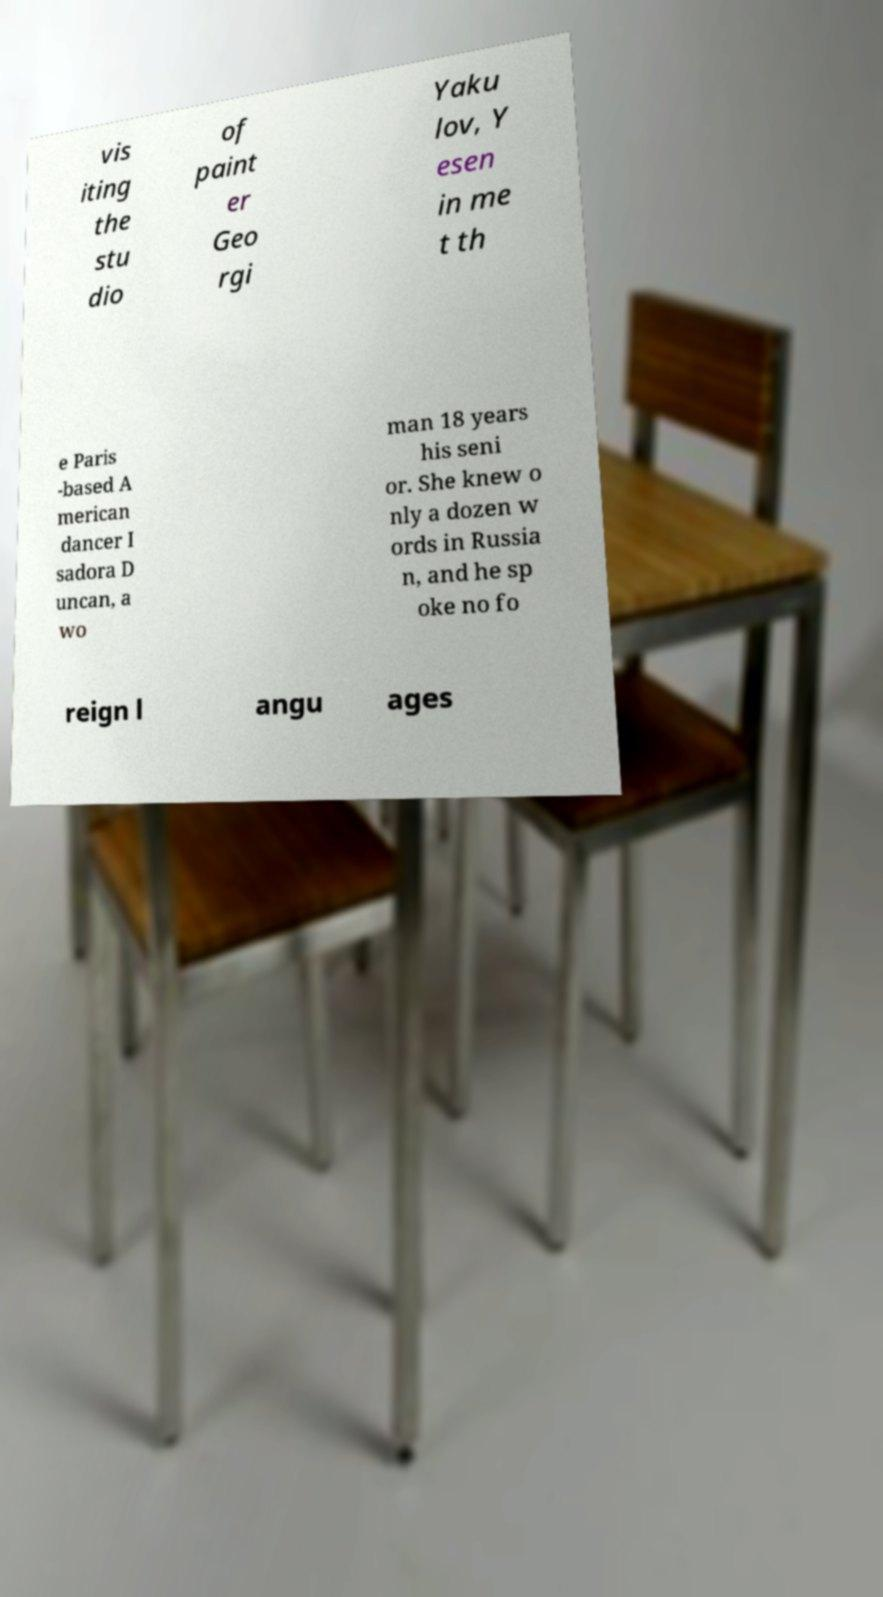What messages or text are displayed in this image? I need them in a readable, typed format. vis iting the stu dio of paint er Geo rgi Yaku lov, Y esen in me t th e Paris -based A merican dancer I sadora D uncan, a wo man 18 years his seni or. She knew o nly a dozen w ords in Russia n, and he sp oke no fo reign l angu ages 